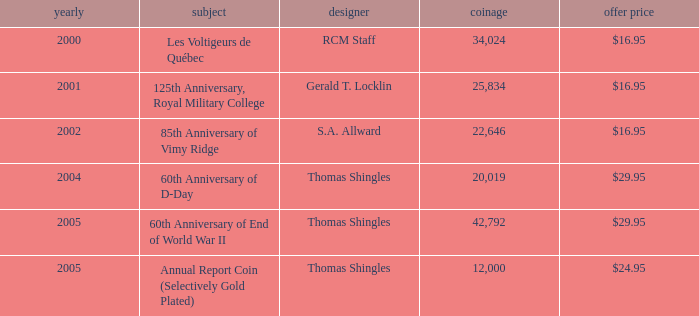What year was S.A. Allward's theme that had an issue price of $16.95 released? 2002.0. 